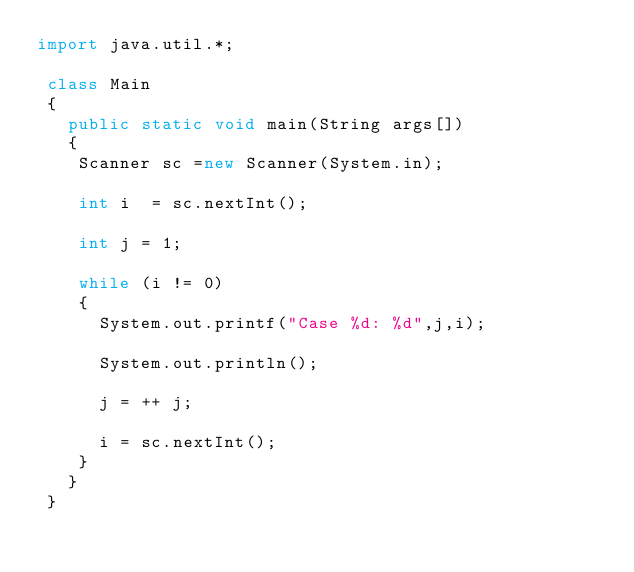Convert code to text. <code><loc_0><loc_0><loc_500><loc_500><_Java_>import java.util.*;

 class Main
 {
   public static void main(String args[])
   { 
    Scanner sc =new Scanner(System.in);
    
    int i  = sc.nextInt();
    
    int j = 1;
    
    while (i != 0)
    {
      System.out.printf("Case %d: %d",j,i);
      
      System.out.println();
      
      j = ++ j;
      
      i = sc.nextInt();
    }
   }
 }
    
    
</code> 